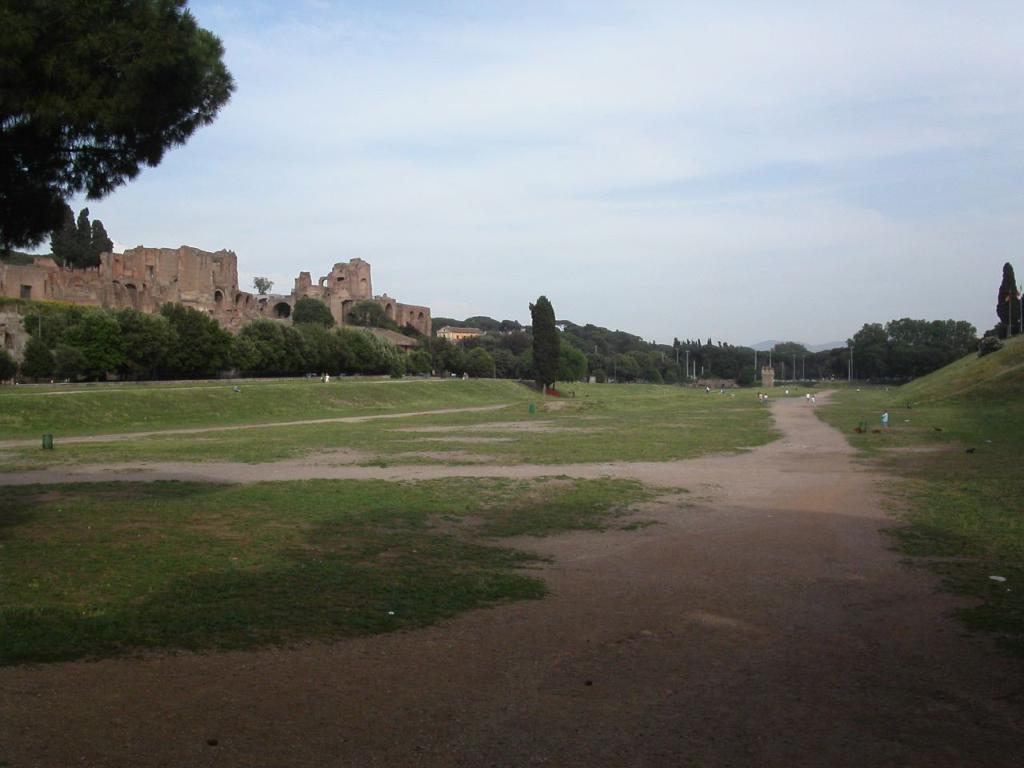What is the main structure in the image? There is a fort in the image. What can be seen in front of the fort? There are trees, plants, grass, people, and a path in front of the fort. How many elements are present in front of the fort? There are six elements present in front of the fort: trees, plants, grass, people, and a path. What is visible in the background of the image? The sky is visible in the background of the image. What type of stick can be seen being used for health purposes in the image? There is no stick or health-related activity present in the image. 